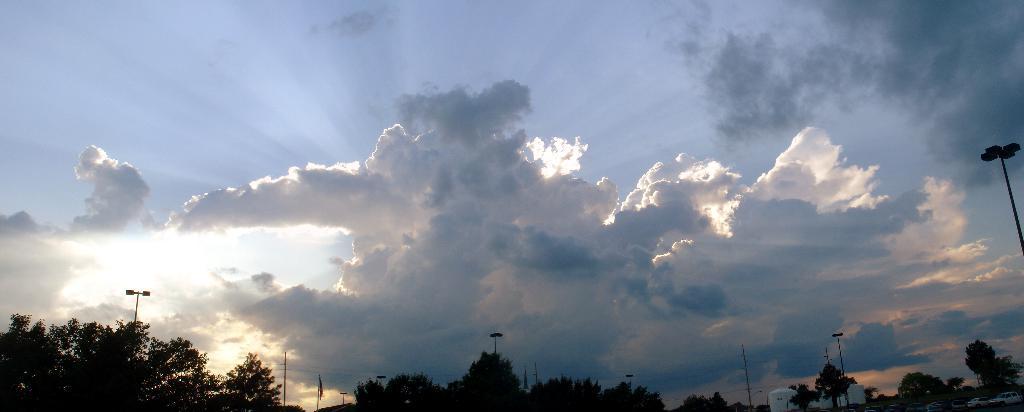Describe this image in one or two sentences. In this image, we can see a cloudy sky. At the bottom of the image, we can see so many trees, poles, flag, vehicles, containers and wires. 